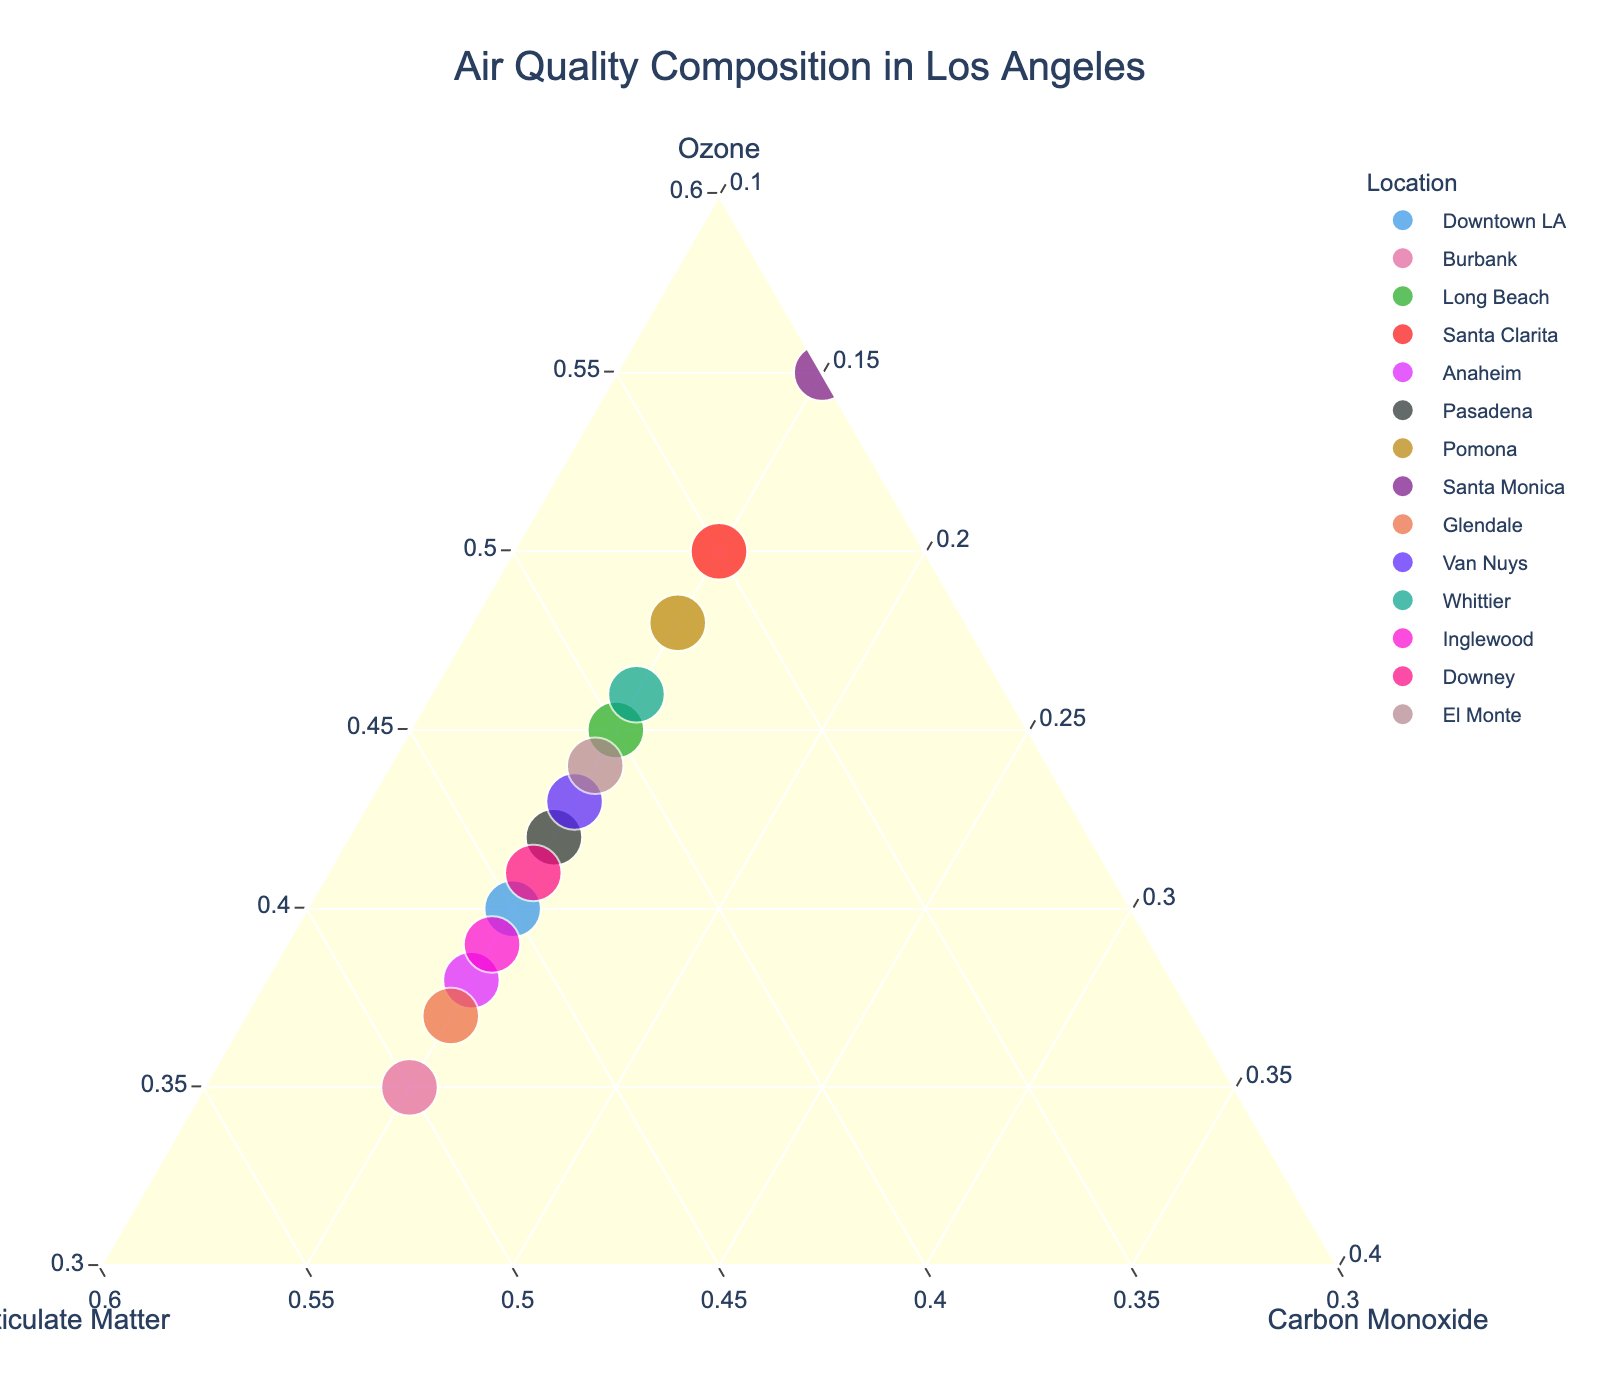What is the title of the figure? The title of the figure is usually placed at the top center of the plot. By looking at the plot, it reads "Air Quality Composition in Los Angeles".
Answer: Air Quality Composition in Los Angeles Which location has the highest ozone percentage? To find the highest ozone percentage, observe the point that is closest to the "Ozone" axis and farthest from the "Particulate Matter" and "Carbon Monoxide" corners. Santa Monica is closest to the ozone axis.
Answer: Santa Monica How many locations are plotted in the figure? Count the number of unique data points or locations shown in the plot. Each point represents a location and there are 14 points in total.
Answer: 14 What is the percentage composition of carbon monoxide for all the locations? The carbon monoxide percentage for each location is displayed as 15%. This can be confirmed by looking at the hover text for any point.
Answer: 15% Which location has the lowest particulate matter percentage? Locate the point nearest to the "Particulate Matter" corner or farthest from the "Particulate Matter" axis. Santa Monica is closest to the axis indicating the lowest particulate matter.
Answer: Santa Monica Is there any location with equal percentages of ozone and particulate matter? Compare the ozone and particulate matter percentages for each location. None of the hover texts shows equal percentages of ozone and particulate matter.
Answer: No What is the range of ozone percentages across all locations? Identify the minimum and maximum ozone percentages. The lowest is in Burbank (35%) and the highest in Santa Monica (55%). The range is 55% - 35%.
Answer: 20% Which location has a higher ozone percentage: Glendale or Anaheim? Compare the ozone percentage from the hover text for Glendale (37%) and Anaheim (38%). Anaheim has a higher percentage.
Answer: Anaheim What is the average particulate matter percentage across all locations? Sum all the particulate matter percentages and divide by the number of locations (45+50+40+35+47+43+37+30+48+42+39+46+44+41)/14 = 42.5%.
Answer: 42.5% Which quadrant contains most of the points, higher ozone and lower particulate matter or higher particulate matter and lower ozone? By visually inspecting, most points are in the quadrant with higher ozone and lower particulate matter.
Answer: Higher ozone and lower particulate matter 